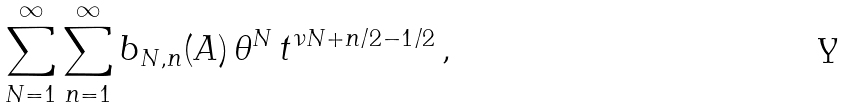Convert formula to latex. <formula><loc_0><loc_0><loc_500><loc_500>\sum _ { N = 1 } ^ { \infty } \sum _ { n = 1 } ^ { \infty } b _ { N , n } ( A ) \, \theta ^ { N } \, t ^ { \nu N + n / 2 - 1 / 2 } \, ,</formula> 